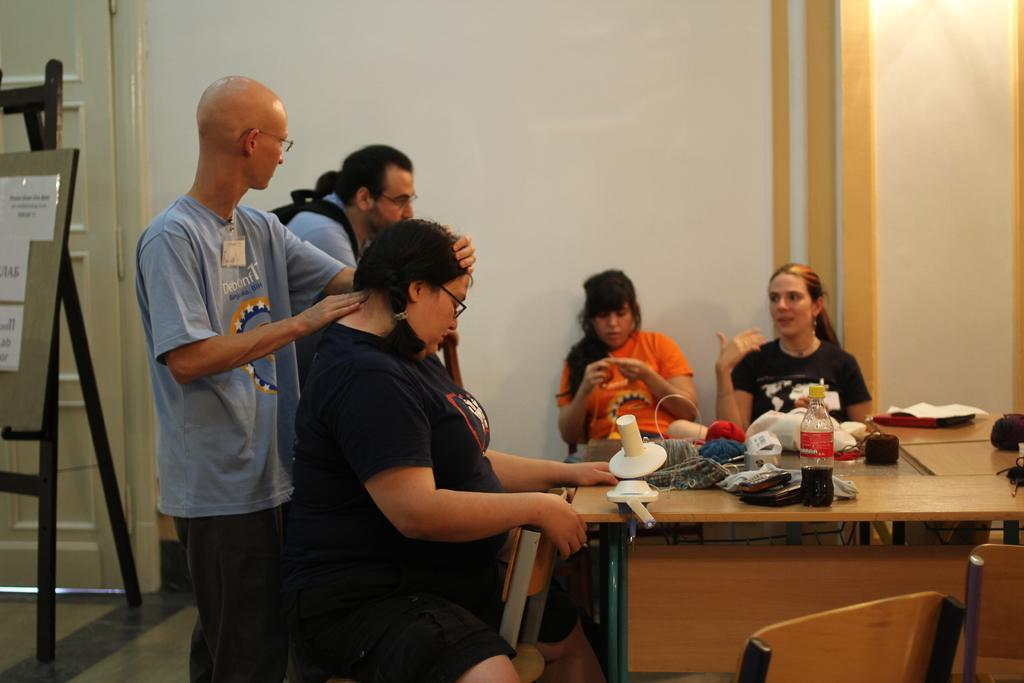How many people are in the image? There are multiple people in the image. What positions are the people in? Two of the people are standing, and the rest are sitting. What is present on the table in the image? There is a bottle and additional items on the table. What furniture is visible in the image? There is a table and chairs in the image. Where is the nest located in the image? There is no nest present in the image. What type of stamp is being used by the people in the image? There is no stamp being used by the people in the image. 